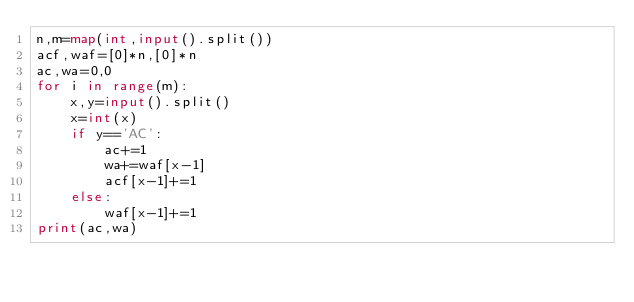Convert code to text. <code><loc_0><loc_0><loc_500><loc_500><_Python_>n,m=map(int,input().split())
acf,waf=[0]*n,[0]*n
ac,wa=0,0
for i in range(m):
    x,y=input().split()
    x=int(x)
    if y=='AC':
        ac+=1
        wa+=waf[x-1]
        acf[x-1]+=1
    else:
        waf[x-1]+=1
print(ac,wa)
</code> 